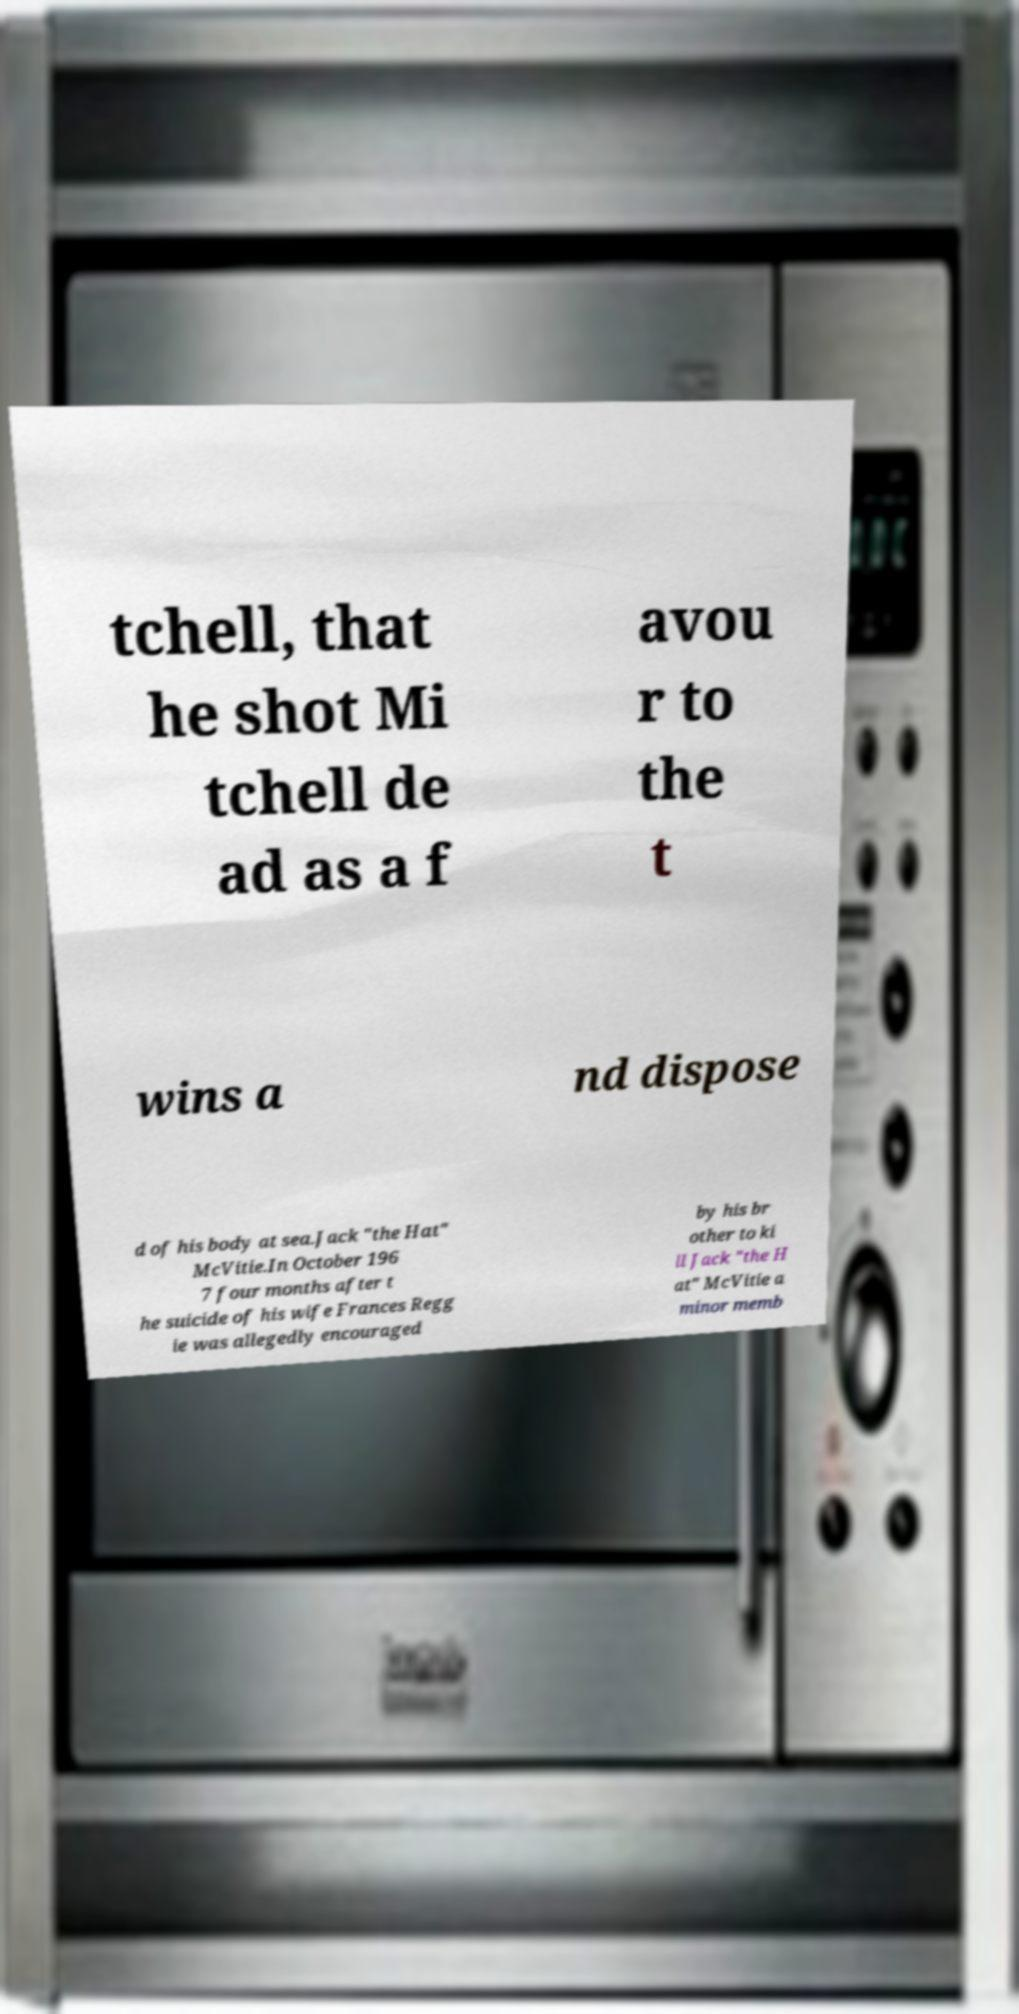Could you assist in decoding the text presented in this image and type it out clearly? tchell, that he shot Mi tchell de ad as a f avou r to the t wins a nd dispose d of his body at sea.Jack "the Hat" McVitie.In October 196 7 four months after t he suicide of his wife Frances Regg ie was allegedly encouraged by his br other to ki ll Jack "the H at" McVitie a minor memb 